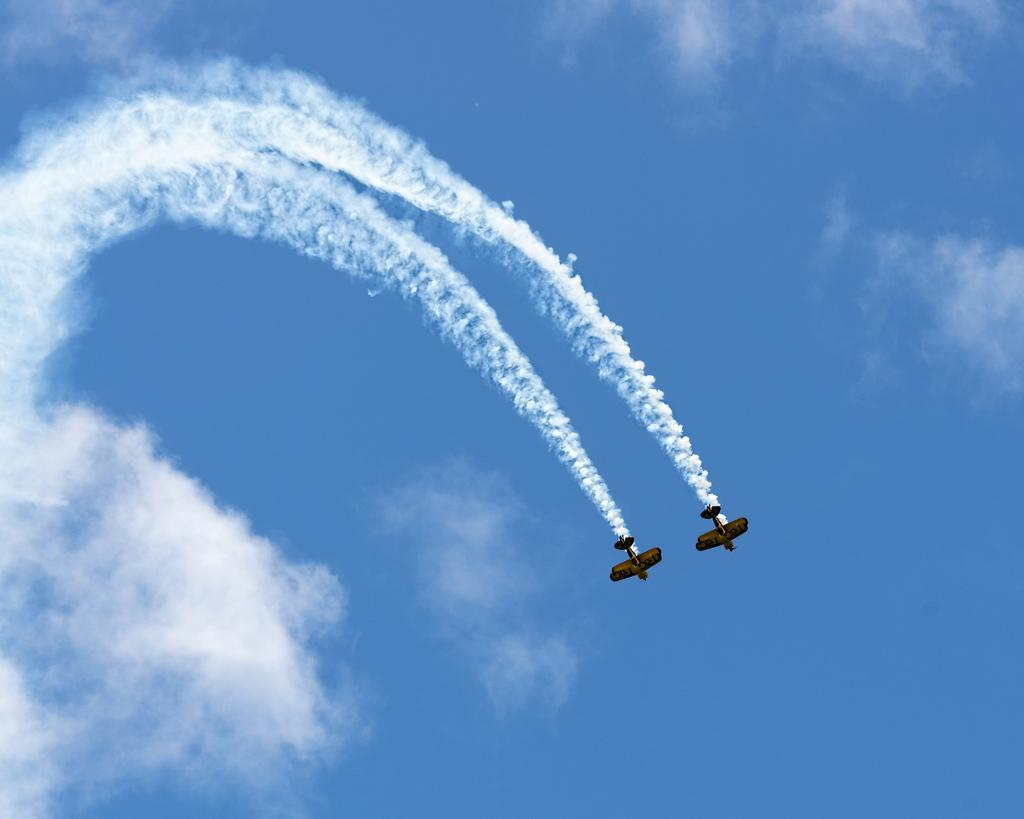What event is taking place in the image? There is an airshow in the image. What can be seen in the background of the image? The sky is visible in the background of the image. Can you see any snakes slithering on the ground during the airshow in the image? There are no snakes visible in the image; it features an airshow with aircraft in the sky. What type of root is growing near the airshow in the image? There is no root present in the image; it is an aerial view of an airshow. 